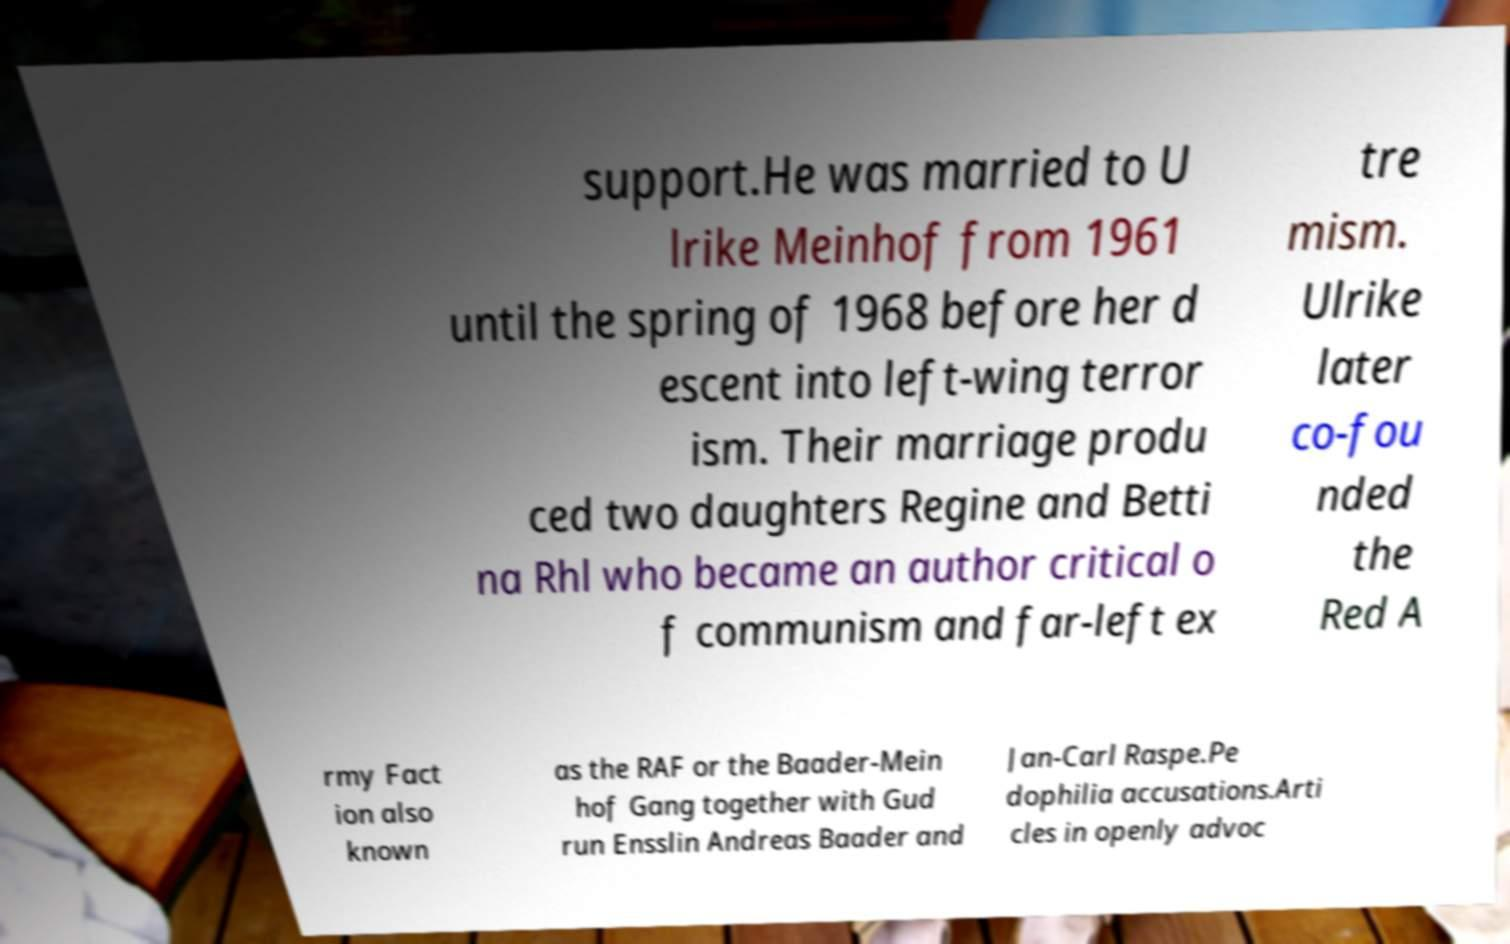There's text embedded in this image that I need extracted. Can you transcribe it verbatim? support.He was married to U lrike Meinhof from 1961 until the spring of 1968 before her d escent into left-wing terror ism. Their marriage produ ced two daughters Regine and Betti na Rhl who became an author critical o f communism and far-left ex tre mism. Ulrike later co-fou nded the Red A rmy Fact ion also known as the RAF or the Baader-Mein hof Gang together with Gud run Ensslin Andreas Baader and Jan-Carl Raspe.Pe dophilia accusations.Arti cles in openly advoc 